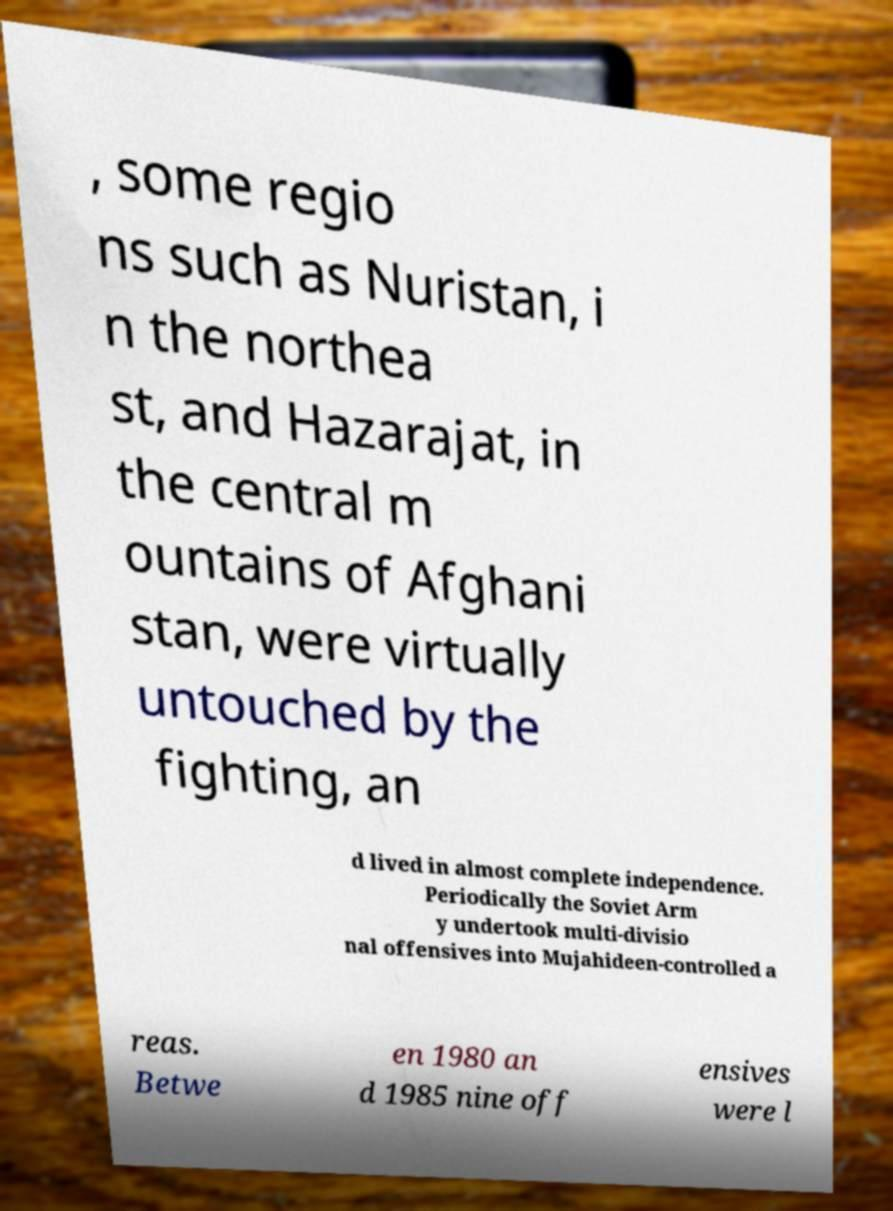There's text embedded in this image that I need extracted. Can you transcribe it verbatim? , some regio ns such as Nuristan, i n the northea st, and Hazarajat, in the central m ountains of Afghani stan, were virtually untouched by the fighting, an d lived in almost complete independence. Periodically the Soviet Arm y undertook multi-divisio nal offensives into Mujahideen-controlled a reas. Betwe en 1980 an d 1985 nine off ensives were l 